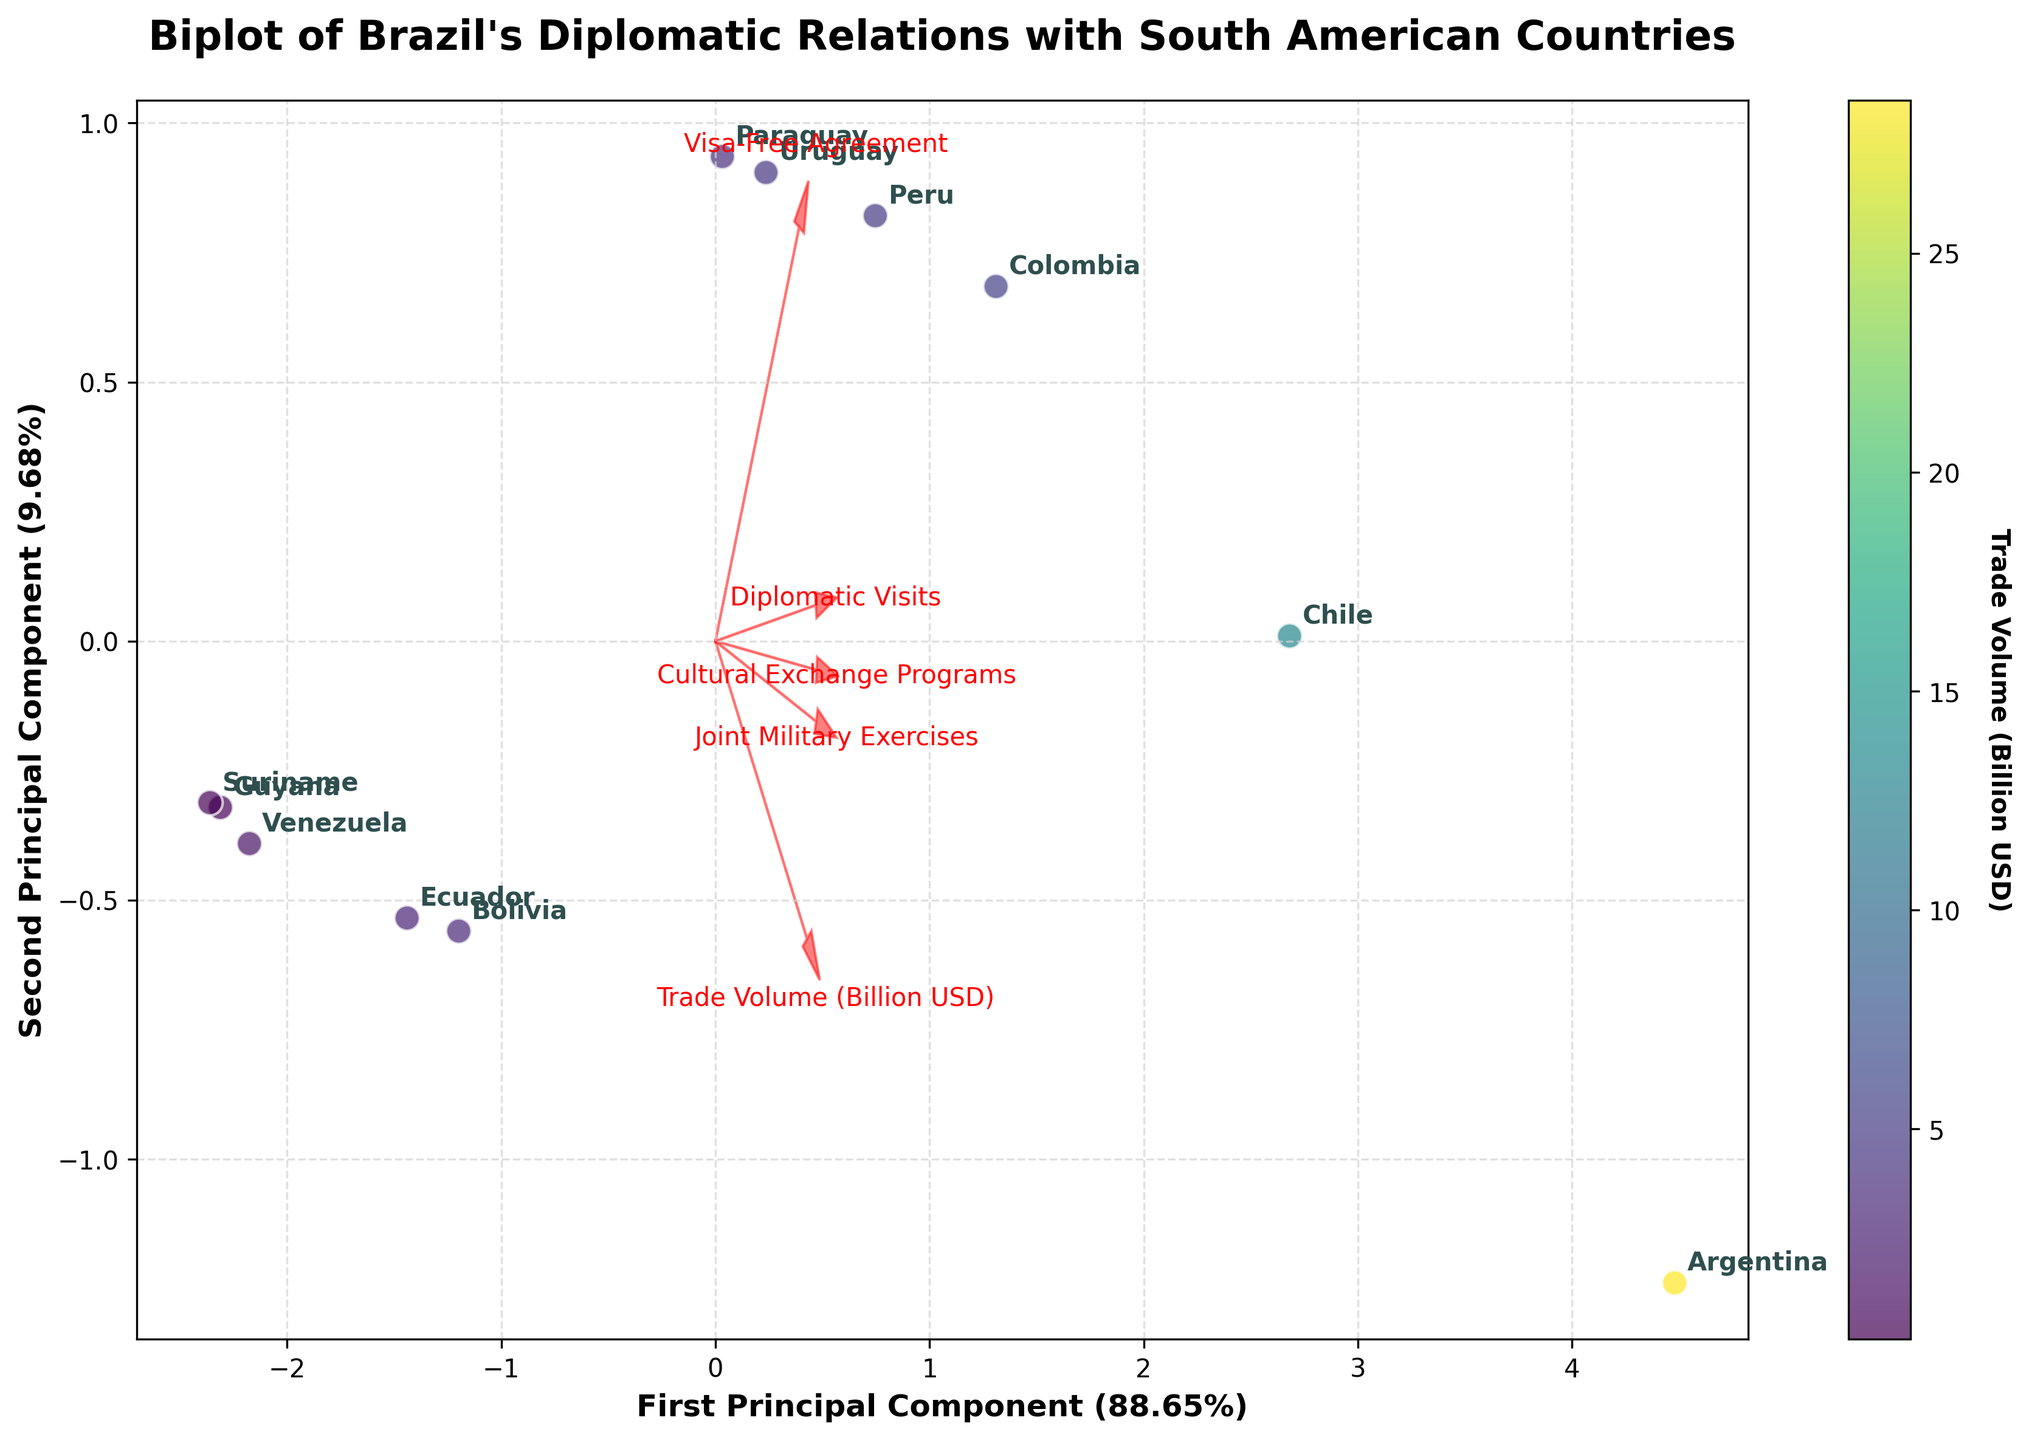Which country has the highest trade volume with Brazil? By looking at the color of the data points and finding the one with the largest value on the color bar, we see that Argentina has the highest trade volume.
Answer: Argentina Which country participates in the most joint military exercises with Brazil? By observing the direction and length of the arrow for "Joint Military Exercises" and the countries' positions, Argentina has the highest participation in joint military exercises.
Answer: Argentina Among the countries shown, how many have a Visa-Free Agreement with Brazil? The arrow for "Visa-Free Agreement" helps identify the countries. Most countries are clustered around that arrow. Counting the data points near this arrow, we identify 7 countries.
Answer: 7 Which feature has the most influence on the second principal component in the biplot? We look at the projections of the feature vectors on the second principal component axis. "Diplomatic Visits" has the longest projection on the second principal component.
Answer: Diplomatic Visits Based on the plot, which country shows the lowest diplomatic interaction with Brazil, considering multiple dimensions? Venezuela is positioned on the extreme negative side of both principal components and has shorter vectors indicating lower values in most features.
Answer: Venezuela Which two countries have similar levels of cultural exchange programs with Brazil? Observing the positions relative to the "Cultural Exchange Programs" vector, Chile and Colombia are close to each other, indicating similar levels of cultural exchange.
Answer: Chile and Colombia How much of the data’s variance is explained by the first principal component? The label of the first principal component axis indicates the percentage of variance it explains. According to the plot, it explains 48.6% of the variance.
Answer: 48.6% Is there any country that appears to have a similar diplomatic profile for both the first and second principal components? Countries with positions close to the origin share similar profiles. Paraguay and Peru are closest together near the origin.
Answer: Paraguay and Peru 